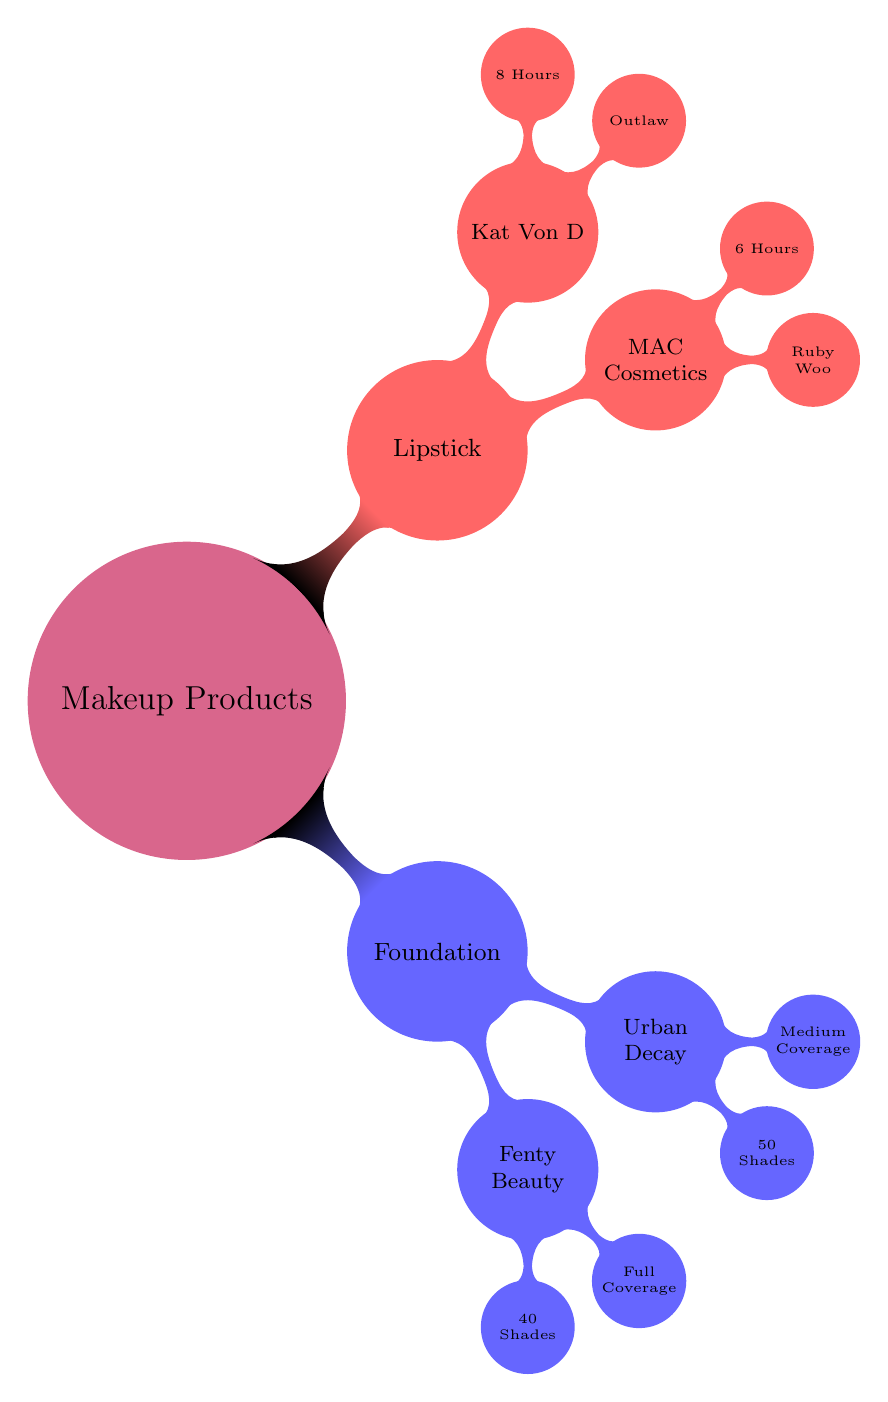What are the two types of makeup products listed? The diagram shows "Foundation" and "Lipstick" as the two main types of makeup products. These are the primary categories branching out from the central node labeled "Makeup Products."
Answer: Foundation, Lipstick How many shades does Fenty Beauty offer? According to the diagram, Fenty Beauty offers "40 Shades" of foundation. This information is found directly under the Fenty Beauty node linked to the Foundation category.
Answer: 40 Shades Which brand has a full coverage foundation? The diagram indicates that "Fenty Beauty" offers full coverage for its foundation. This is explicitly mentioned under the Fenty Beauty node connected to the Foundation category.
Answer: Fenty Beauty What is the duration of Kat Von D lipstick? The diagram states that Kat Von D's lipstick "Outlaw" lasts for "8 Hours." This detail is found under the Kat Von D node within the Lipstick category.
Answer: 8 Hours Which brand offers the most shades for foundation? The diagram reveals that "Urban Decay" provides "50 Shades" of foundation, which is more than Fenty Beauty. This information is located under the Urban Decay node, and comparing it to Fenty Beauty shows that Urban Decay has more shades.
Answer: 50 Shades What is the coverage type for Urban Decay foundation? The diagram specifies that Urban Decay provides "Medium Coverage" for its foundation. This detail is positioned directly under the Urban Decay node connected to the Foundation category.
Answer: Medium Coverage Which lipstick lasts longer, MAC Cosmetics or Kat Von D? The diagram shows MAC Cosmetics lipstick lasts for "6 Hours," while Kat Von D lasts for "8 Hours." Since 8 is greater than 6, it indicates Kat Von D's lipstick lasts longer.
Answer: Kat Von D How many nodes are there under the Lipstick category? The diagram shows two nodes under the Lipstick category: one for MAC Cosmetics and the other for Kat Von D. Counting these nodes directly provides the answer.
Answer: 2 What type of diagram is this? This diagram is identified as a "Comparison chart of different makeup products," as seen from the central node labeled "Makeup Products" and its subdivisions.
Answer: Comparison chart 